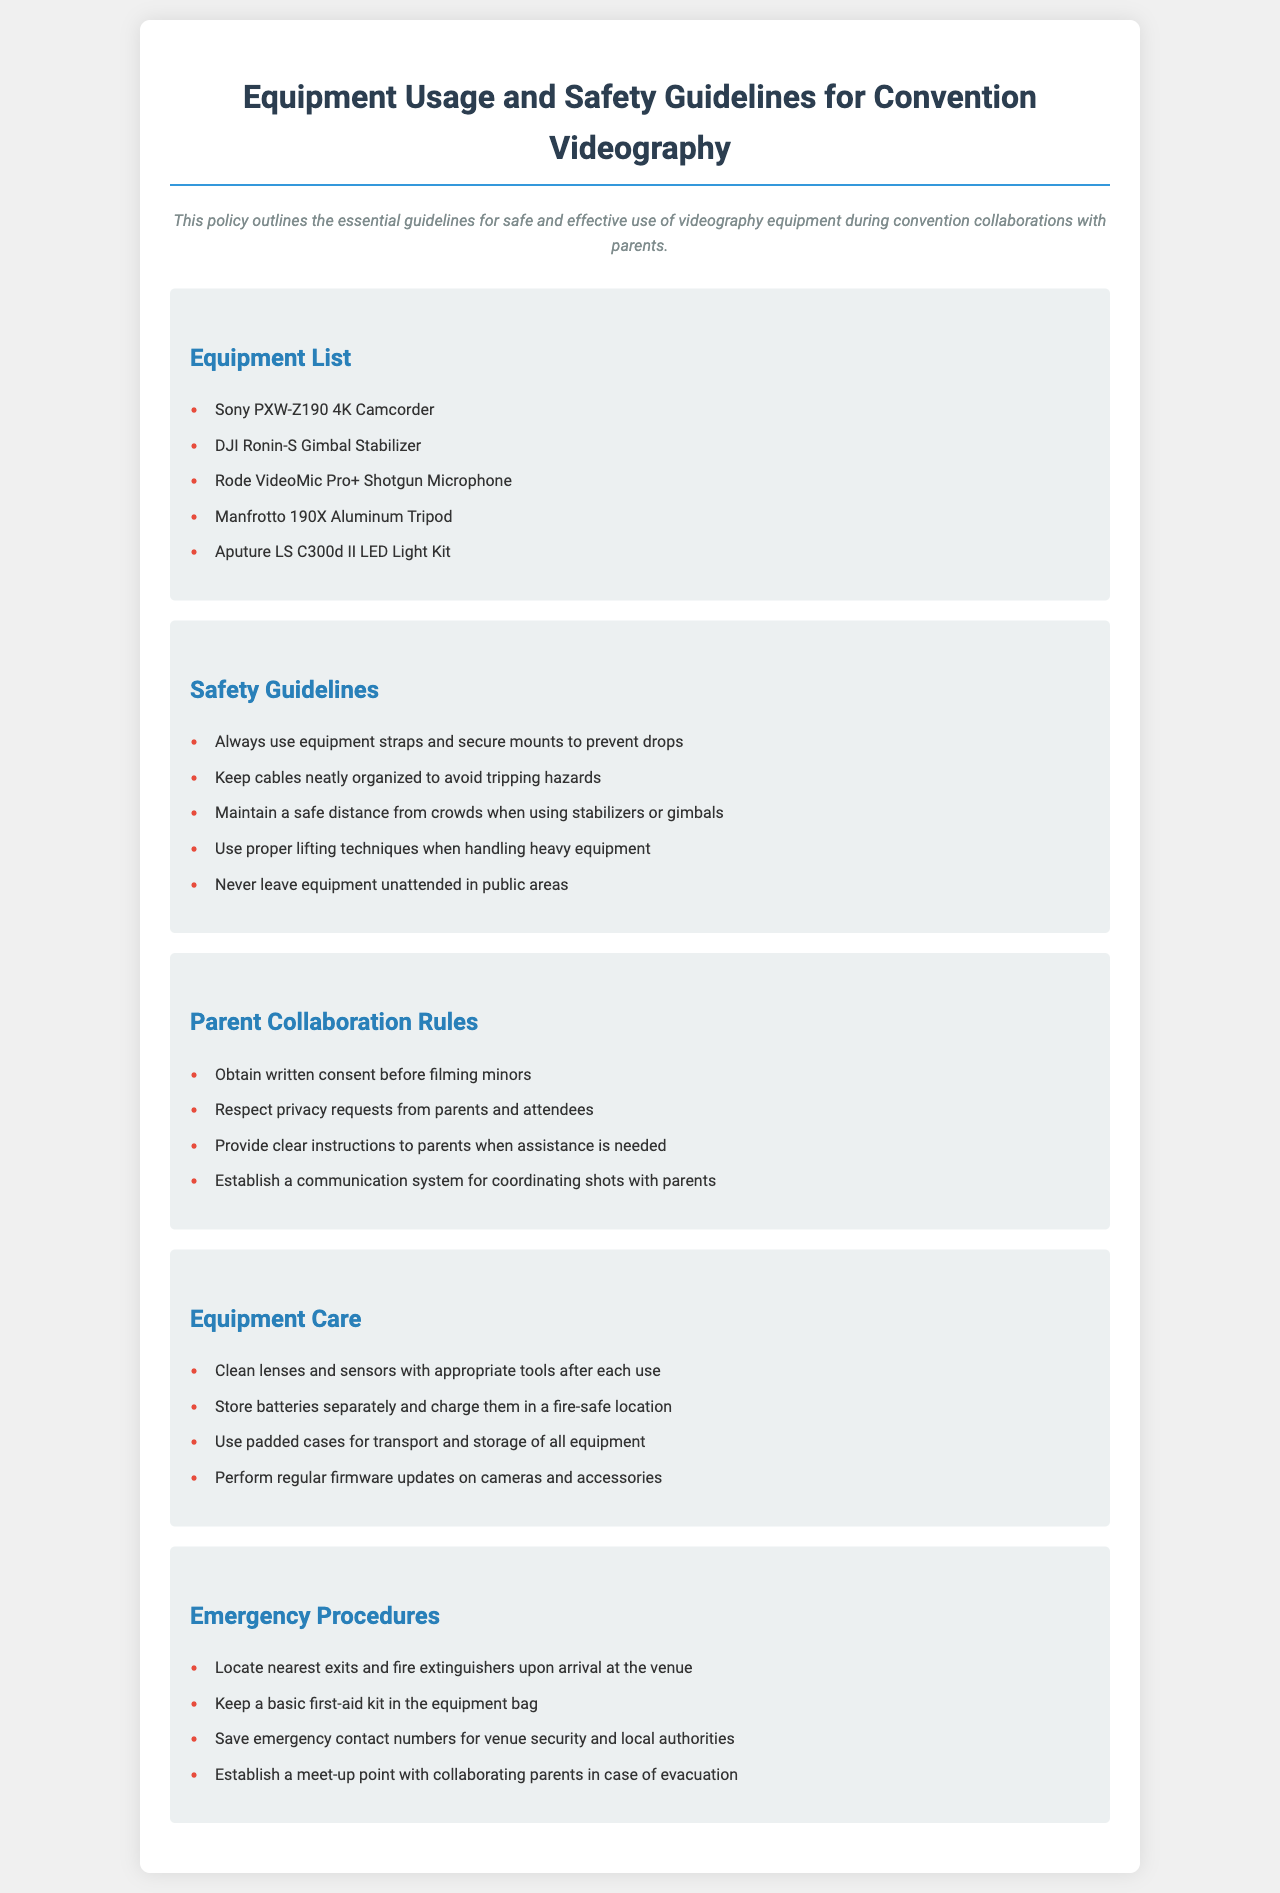What is the main purpose of the policy document? The document outlines the essential guidelines for safe and effective use of videography equipment during convention collaborations with parents.
Answer: Guidelines for safe and effective use of equipment How many items are in the equipment list? The equipment section contains a list of five items.
Answer: Five items What is one of the safety guidelines regarding cables? The document states that keeping cables neatly organized helps avoid tripping hazards.
Answer: Avoid tripping hazards What should you do before filming minors? The document specifies obtaining written consent before filming minors.
Answer: Obtain written consent What type of cases should be used for transporting equipment? The guideline recommends using padded cases for equipment transport and storage.
Answer: Padded cases What should you keep in the equipment bag for emergencies? A basic first-aid kit should be kept in the equipment bag for emergencies.
Answer: First-aid kit Who should you establish a communication system with? You should establish a communication system for coordinating shots with parents.
Answer: Parents What is one key item to store separately? The document mentions that batteries should be stored separately.
Answer: Batteries 